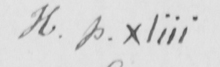Can you read and transcribe this handwriting? H p . xliii 